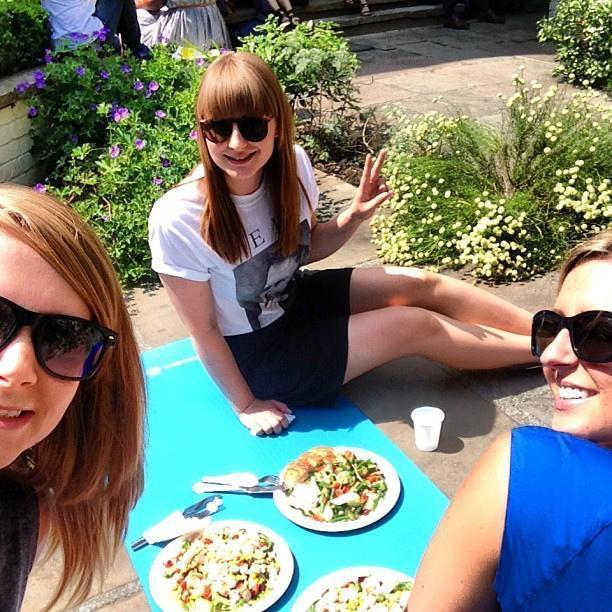How many people are in the picture?
Give a very brief answer. 5. How many cars are in the picture?
Give a very brief answer. 0. 